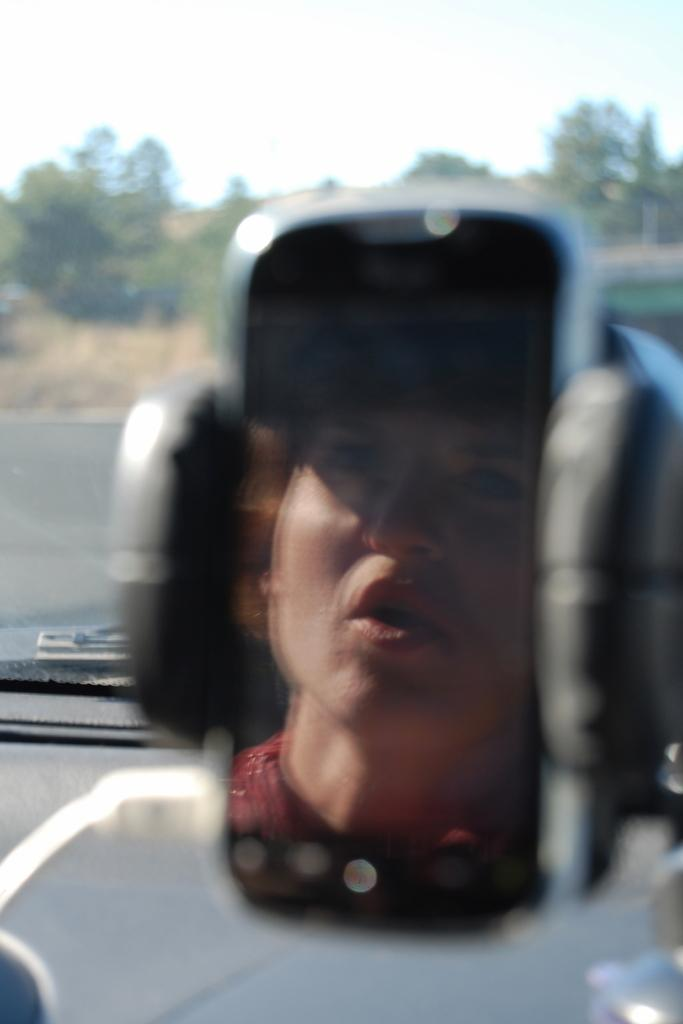What is the main object in the image with a stand? There is a gadget with a stand in the image. What can be seen on the gadget's screen? The gadget's screen displays a person's face. What type of natural scenery is visible in the background of the image? There are trees in the background of the background of the image. What else can be seen in the background of the image? The sky is visible in the background of the image. Where are the cherries placed on the gadget's screen? There are no cherries present on the gadget's screen or in the image. What type of plant is growing on the gadget's stand? There is no plant growing on the gadget's stand or in the image. 